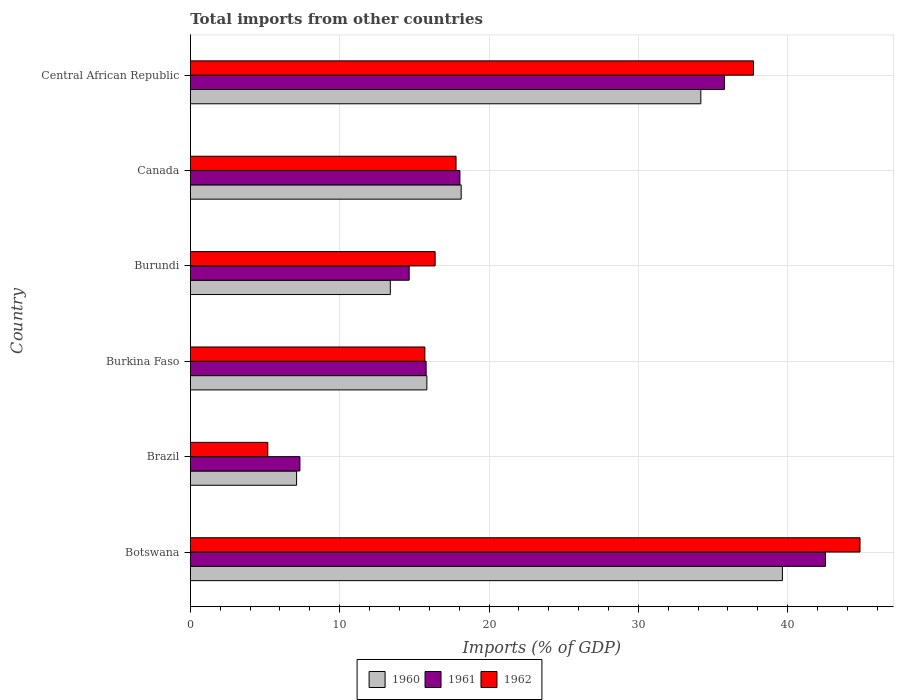How many different coloured bars are there?
Your response must be concise. 3. Are the number of bars per tick equal to the number of legend labels?
Provide a succinct answer. Yes. Are the number of bars on each tick of the Y-axis equal?
Your answer should be compact. Yes. How many bars are there on the 2nd tick from the top?
Your answer should be very brief. 3. How many bars are there on the 6th tick from the bottom?
Provide a succinct answer. 3. What is the label of the 6th group of bars from the top?
Provide a short and direct response. Botswana. In how many cases, is the number of bars for a given country not equal to the number of legend labels?
Ensure brevity in your answer.  0. What is the total imports in 1962 in Burundi?
Ensure brevity in your answer.  16.39. Across all countries, what is the maximum total imports in 1962?
Provide a succinct answer. 44.84. Across all countries, what is the minimum total imports in 1961?
Provide a short and direct response. 7.34. In which country was the total imports in 1960 maximum?
Offer a terse response. Botswana. In which country was the total imports in 1960 minimum?
Offer a very short reply. Brazil. What is the total total imports in 1962 in the graph?
Your response must be concise. 137.63. What is the difference between the total imports in 1962 in Botswana and that in Brazil?
Provide a short and direct response. 39.65. What is the difference between the total imports in 1962 in Central African Republic and the total imports in 1960 in Botswana?
Give a very brief answer. -1.94. What is the average total imports in 1961 per country?
Offer a very short reply. 22.35. What is the difference between the total imports in 1961 and total imports in 1962 in Canada?
Make the answer very short. 0.26. In how many countries, is the total imports in 1960 greater than 8 %?
Make the answer very short. 5. What is the ratio of the total imports in 1962 in Botswana to that in Brazil?
Make the answer very short. 8.64. Is the total imports in 1960 in Botswana less than that in Brazil?
Your answer should be very brief. No. Is the difference between the total imports in 1961 in Brazil and Burkina Faso greater than the difference between the total imports in 1962 in Brazil and Burkina Faso?
Your answer should be compact. Yes. What is the difference between the highest and the second highest total imports in 1961?
Your answer should be compact. 6.76. What is the difference between the highest and the lowest total imports in 1962?
Make the answer very short. 39.65. In how many countries, is the total imports in 1960 greater than the average total imports in 1960 taken over all countries?
Ensure brevity in your answer.  2. What does the 3rd bar from the top in Burkina Faso represents?
Offer a terse response. 1960. What does the 3rd bar from the bottom in Burundi represents?
Offer a very short reply. 1962. Is it the case that in every country, the sum of the total imports in 1962 and total imports in 1961 is greater than the total imports in 1960?
Provide a short and direct response. Yes. Are all the bars in the graph horizontal?
Provide a succinct answer. Yes. How many countries are there in the graph?
Ensure brevity in your answer.  6. Where does the legend appear in the graph?
Ensure brevity in your answer.  Bottom center. What is the title of the graph?
Your response must be concise. Total imports from other countries. Does "1985" appear as one of the legend labels in the graph?
Give a very brief answer. No. What is the label or title of the X-axis?
Make the answer very short. Imports (% of GDP). What is the label or title of the Y-axis?
Keep it short and to the point. Country. What is the Imports (% of GDP) in 1960 in Botswana?
Your answer should be compact. 39.64. What is the Imports (% of GDP) in 1961 in Botswana?
Provide a succinct answer. 42.53. What is the Imports (% of GDP) in 1962 in Botswana?
Offer a very short reply. 44.84. What is the Imports (% of GDP) in 1960 in Brazil?
Offer a terse response. 7.12. What is the Imports (% of GDP) of 1961 in Brazil?
Give a very brief answer. 7.34. What is the Imports (% of GDP) in 1962 in Brazil?
Make the answer very short. 5.19. What is the Imports (% of GDP) of 1960 in Burkina Faso?
Make the answer very short. 15.84. What is the Imports (% of GDP) of 1961 in Burkina Faso?
Give a very brief answer. 15.79. What is the Imports (% of GDP) in 1962 in Burkina Faso?
Offer a terse response. 15.71. What is the Imports (% of GDP) of 1960 in Burundi?
Your answer should be very brief. 13.39. What is the Imports (% of GDP) in 1961 in Burundi?
Provide a short and direct response. 14.66. What is the Imports (% of GDP) in 1962 in Burundi?
Your answer should be compact. 16.39. What is the Imports (% of GDP) of 1960 in Canada?
Ensure brevity in your answer.  18.14. What is the Imports (% of GDP) in 1961 in Canada?
Give a very brief answer. 18.05. What is the Imports (% of GDP) in 1962 in Canada?
Your answer should be very brief. 17.79. What is the Imports (% of GDP) of 1960 in Central African Republic?
Make the answer very short. 34.18. What is the Imports (% of GDP) in 1961 in Central African Republic?
Your answer should be very brief. 35.76. What is the Imports (% of GDP) of 1962 in Central African Republic?
Offer a very short reply. 37.7. Across all countries, what is the maximum Imports (% of GDP) of 1960?
Offer a terse response. 39.64. Across all countries, what is the maximum Imports (% of GDP) of 1961?
Your answer should be very brief. 42.53. Across all countries, what is the maximum Imports (% of GDP) in 1962?
Offer a very short reply. 44.84. Across all countries, what is the minimum Imports (% of GDP) in 1960?
Offer a terse response. 7.12. Across all countries, what is the minimum Imports (% of GDP) of 1961?
Make the answer very short. 7.34. Across all countries, what is the minimum Imports (% of GDP) of 1962?
Make the answer very short. 5.19. What is the total Imports (% of GDP) in 1960 in the graph?
Keep it short and to the point. 128.31. What is the total Imports (% of GDP) of 1961 in the graph?
Your response must be concise. 134.12. What is the total Imports (% of GDP) of 1962 in the graph?
Make the answer very short. 137.63. What is the difference between the Imports (% of GDP) of 1960 in Botswana and that in Brazil?
Your answer should be very brief. 32.53. What is the difference between the Imports (% of GDP) of 1961 in Botswana and that in Brazil?
Provide a succinct answer. 35.19. What is the difference between the Imports (% of GDP) of 1962 in Botswana and that in Brazil?
Offer a terse response. 39.65. What is the difference between the Imports (% of GDP) in 1960 in Botswana and that in Burkina Faso?
Your answer should be compact. 23.8. What is the difference between the Imports (% of GDP) of 1961 in Botswana and that in Burkina Faso?
Make the answer very short. 26.74. What is the difference between the Imports (% of GDP) in 1962 in Botswana and that in Burkina Faso?
Keep it short and to the point. 29.13. What is the difference between the Imports (% of GDP) in 1960 in Botswana and that in Burundi?
Ensure brevity in your answer.  26.25. What is the difference between the Imports (% of GDP) in 1961 in Botswana and that in Burundi?
Ensure brevity in your answer.  27.87. What is the difference between the Imports (% of GDP) of 1962 in Botswana and that in Burundi?
Make the answer very short. 28.45. What is the difference between the Imports (% of GDP) in 1960 in Botswana and that in Canada?
Your answer should be compact. 21.51. What is the difference between the Imports (% of GDP) in 1961 in Botswana and that in Canada?
Your answer should be compact. 24.47. What is the difference between the Imports (% of GDP) of 1962 in Botswana and that in Canada?
Provide a short and direct response. 27.05. What is the difference between the Imports (% of GDP) of 1960 in Botswana and that in Central African Republic?
Offer a terse response. 5.46. What is the difference between the Imports (% of GDP) of 1961 in Botswana and that in Central African Republic?
Offer a very short reply. 6.76. What is the difference between the Imports (% of GDP) in 1962 in Botswana and that in Central African Republic?
Ensure brevity in your answer.  7.13. What is the difference between the Imports (% of GDP) in 1960 in Brazil and that in Burkina Faso?
Your answer should be compact. -8.72. What is the difference between the Imports (% of GDP) of 1961 in Brazil and that in Burkina Faso?
Your answer should be compact. -8.45. What is the difference between the Imports (% of GDP) of 1962 in Brazil and that in Burkina Faso?
Your answer should be compact. -10.52. What is the difference between the Imports (% of GDP) of 1960 in Brazil and that in Burundi?
Keep it short and to the point. -6.28. What is the difference between the Imports (% of GDP) of 1961 in Brazil and that in Burundi?
Offer a terse response. -7.32. What is the difference between the Imports (% of GDP) of 1962 in Brazil and that in Burundi?
Your response must be concise. -11.2. What is the difference between the Imports (% of GDP) of 1960 in Brazil and that in Canada?
Provide a short and direct response. -11.02. What is the difference between the Imports (% of GDP) in 1961 in Brazil and that in Canada?
Give a very brief answer. -10.71. What is the difference between the Imports (% of GDP) in 1962 in Brazil and that in Canada?
Your answer should be very brief. -12.6. What is the difference between the Imports (% of GDP) in 1960 in Brazil and that in Central African Republic?
Ensure brevity in your answer.  -27.06. What is the difference between the Imports (% of GDP) in 1961 in Brazil and that in Central African Republic?
Your response must be concise. -28.42. What is the difference between the Imports (% of GDP) of 1962 in Brazil and that in Central African Republic?
Make the answer very short. -32.52. What is the difference between the Imports (% of GDP) of 1960 in Burkina Faso and that in Burundi?
Provide a succinct answer. 2.45. What is the difference between the Imports (% of GDP) of 1961 in Burkina Faso and that in Burundi?
Provide a short and direct response. 1.13. What is the difference between the Imports (% of GDP) in 1962 in Burkina Faso and that in Burundi?
Keep it short and to the point. -0.69. What is the difference between the Imports (% of GDP) in 1960 in Burkina Faso and that in Canada?
Offer a terse response. -2.3. What is the difference between the Imports (% of GDP) of 1961 in Burkina Faso and that in Canada?
Keep it short and to the point. -2.26. What is the difference between the Imports (% of GDP) of 1962 in Burkina Faso and that in Canada?
Provide a short and direct response. -2.09. What is the difference between the Imports (% of GDP) in 1960 in Burkina Faso and that in Central African Republic?
Ensure brevity in your answer.  -18.34. What is the difference between the Imports (% of GDP) of 1961 in Burkina Faso and that in Central African Republic?
Ensure brevity in your answer.  -19.97. What is the difference between the Imports (% of GDP) in 1962 in Burkina Faso and that in Central African Republic?
Give a very brief answer. -22. What is the difference between the Imports (% of GDP) of 1960 in Burundi and that in Canada?
Keep it short and to the point. -4.74. What is the difference between the Imports (% of GDP) of 1961 in Burundi and that in Canada?
Offer a terse response. -3.4. What is the difference between the Imports (% of GDP) in 1962 in Burundi and that in Canada?
Offer a very short reply. -1.4. What is the difference between the Imports (% of GDP) in 1960 in Burundi and that in Central African Republic?
Offer a terse response. -20.79. What is the difference between the Imports (% of GDP) of 1961 in Burundi and that in Central African Republic?
Keep it short and to the point. -21.11. What is the difference between the Imports (% of GDP) of 1962 in Burundi and that in Central African Republic?
Your answer should be very brief. -21.31. What is the difference between the Imports (% of GDP) in 1960 in Canada and that in Central African Republic?
Offer a terse response. -16.05. What is the difference between the Imports (% of GDP) of 1961 in Canada and that in Central African Republic?
Your response must be concise. -17.71. What is the difference between the Imports (% of GDP) of 1962 in Canada and that in Central African Republic?
Provide a short and direct response. -19.91. What is the difference between the Imports (% of GDP) in 1960 in Botswana and the Imports (% of GDP) in 1961 in Brazil?
Give a very brief answer. 32.3. What is the difference between the Imports (% of GDP) of 1960 in Botswana and the Imports (% of GDP) of 1962 in Brazil?
Give a very brief answer. 34.45. What is the difference between the Imports (% of GDP) in 1961 in Botswana and the Imports (% of GDP) in 1962 in Brazil?
Your answer should be compact. 37.34. What is the difference between the Imports (% of GDP) of 1960 in Botswana and the Imports (% of GDP) of 1961 in Burkina Faso?
Your answer should be very brief. 23.85. What is the difference between the Imports (% of GDP) of 1960 in Botswana and the Imports (% of GDP) of 1962 in Burkina Faso?
Offer a terse response. 23.94. What is the difference between the Imports (% of GDP) in 1961 in Botswana and the Imports (% of GDP) in 1962 in Burkina Faso?
Provide a short and direct response. 26.82. What is the difference between the Imports (% of GDP) in 1960 in Botswana and the Imports (% of GDP) in 1961 in Burundi?
Your answer should be very brief. 24.99. What is the difference between the Imports (% of GDP) of 1960 in Botswana and the Imports (% of GDP) of 1962 in Burundi?
Your response must be concise. 23.25. What is the difference between the Imports (% of GDP) in 1961 in Botswana and the Imports (% of GDP) in 1962 in Burundi?
Offer a very short reply. 26.13. What is the difference between the Imports (% of GDP) of 1960 in Botswana and the Imports (% of GDP) of 1961 in Canada?
Provide a succinct answer. 21.59. What is the difference between the Imports (% of GDP) of 1960 in Botswana and the Imports (% of GDP) of 1962 in Canada?
Ensure brevity in your answer.  21.85. What is the difference between the Imports (% of GDP) of 1961 in Botswana and the Imports (% of GDP) of 1962 in Canada?
Keep it short and to the point. 24.73. What is the difference between the Imports (% of GDP) in 1960 in Botswana and the Imports (% of GDP) in 1961 in Central African Republic?
Keep it short and to the point. 3.88. What is the difference between the Imports (% of GDP) of 1960 in Botswana and the Imports (% of GDP) of 1962 in Central African Republic?
Provide a succinct answer. 1.94. What is the difference between the Imports (% of GDP) of 1961 in Botswana and the Imports (% of GDP) of 1962 in Central African Republic?
Make the answer very short. 4.82. What is the difference between the Imports (% of GDP) of 1960 in Brazil and the Imports (% of GDP) of 1961 in Burkina Faso?
Your answer should be compact. -8.67. What is the difference between the Imports (% of GDP) in 1960 in Brazil and the Imports (% of GDP) in 1962 in Burkina Faso?
Your answer should be compact. -8.59. What is the difference between the Imports (% of GDP) in 1961 in Brazil and the Imports (% of GDP) in 1962 in Burkina Faso?
Ensure brevity in your answer.  -8.37. What is the difference between the Imports (% of GDP) in 1960 in Brazil and the Imports (% of GDP) in 1961 in Burundi?
Your answer should be compact. -7.54. What is the difference between the Imports (% of GDP) of 1960 in Brazil and the Imports (% of GDP) of 1962 in Burundi?
Provide a short and direct response. -9.28. What is the difference between the Imports (% of GDP) of 1961 in Brazil and the Imports (% of GDP) of 1962 in Burundi?
Provide a short and direct response. -9.05. What is the difference between the Imports (% of GDP) in 1960 in Brazil and the Imports (% of GDP) in 1961 in Canada?
Your response must be concise. -10.93. What is the difference between the Imports (% of GDP) in 1960 in Brazil and the Imports (% of GDP) in 1962 in Canada?
Provide a short and direct response. -10.68. What is the difference between the Imports (% of GDP) in 1961 in Brazil and the Imports (% of GDP) in 1962 in Canada?
Provide a succinct answer. -10.45. What is the difference between the Imports (% of GDP) of 1960 in Brazil and the Imports (% of GDP) of 1961 in Central African Republic?
Your answer should be compact. -28.64. What is the difference between the Imports (% of GDP) in 1960 in Brazil and the Imports (% of GDP) in 1962 in Central African Republic?
Provide a short and direct response. -30.59. What is the difference between the Imports (% of GDP) of 1961 in Brazil and the Imports (% of GDP) of 1962 in Central African Republic?
Ensure brevity in your answer.  -30.37. What is the difference between the Imports (% of GDP) in 1960 in Burkina Faso and the Imports (% of GDP) in 1961 in Burundi?
Offer a very short reply. 1.18. What is the difference between the Imports (% of GDP) of 1960 in Burkina Faso and the Imports (% of GDP) of 1962 in Burundi?
Your response must be concise. -0.55. What is the difference between the Imports (% of GDP) of 1961 in Burkina Faso and the Imports (% of GDP) of 1962 in Burundi?
Your answer should be compact. -0.6. What is the difference between the Imports (% of GDP) in 1960 in Burkina Faso and the Imports (% of GDP) in 1961 in Canada?
Your answer should be compact. -2.21. What is the difference between the Imports (% of GDP) in 1960 in Burkina Faso and the Imports (% of GDP) in 1962 in Canada?
Your response must be concise. -1.95. What is the difference between the Imports (% of GDP) of 1961 in Burkina Faso and the Imports (% of GDP) of 1962 in Canada?
Your answer should be very brief. -2. What is the difference between the Imports (% of GDP) in 1960 in Burkina Faso and the Imports (% of GDP) in 1961 in Central African Republic?
Keep it short and to the point. -19.92. What is the difference between the Imports (% of GDP) of 1960 in Burkina Faso and the Imports (% of GDP) of 1962 in Central African Republic?
Provide a succinct answer. -21.87. What is the difference between the Imports (% of GDP) in 1961 in Burkina Faso and the Imports (% of GDP) in 1962 in Central African Republic?
Keep it short and to the point. -21.91. What is the difference between the Imports (% of GDP) in 1960 in Burundi and the Imports (% of GDP) in 1961 in Canada?
Ensure brevity in your answer.  -4.66. What is the difference between the Imports (% of GDP) of 1960 in Burundi and the Imports (% of GDP) of 1962 in Canada?
Give a very brief answer. -4.4. What is the difference between the Imports (% of GDP) of 1961 in Burundi and the Imports (% of GDP) of 1962 in Canada?
Offer a very short reply. -3.14. What is the difference between the Imports (% of GDP) of 1960 in Burundi and the Imports (% of GDP) of 1961 in Central African Republic?
Give a very brief answer. -22.37. What is the difference between the Imports (% of GDP) in 1960 in Burundi and the Imports (% of GDP) in 1962 in Central African Republic?
Provide a short and direct response. -24.31. What is the difference between the Imports (% of GDP) in 1961 in Burundi and the Imports (% of GDP) in 1962 in Central African Republic?
Offer a terse response. -23.05. What is the difference between the Imports (% of GDP) of 1960 in Canada and the Imports (% of GDP) of 1961 in Central African Republic?
Ensure brevity in your answer.  -17.63. What is the difference between the Imports (% of GDP) in 1960 in Canada and the Imports (% of GDP) in 1962 in Central African Republic?
Offer a terse response. -19.57. What is the difference between the Imports (% of GDP) of 1961 in Canada and the Imports (% of GDP) of 1962 in Central African Republic?
Your response must be concise. -19.65. What is the average Imports (% of GDP) in 1960 per country?
Provide a succinct answer. 21.39. What is the average Imports (% of GDP) of 1961 per country?
Keep it short and to the point. 22.35. What is the average Imports (% of GDP) in 1962 per country?
Make the answer very short. 22.94. What is the difference between the Imports (% of GDP) in 1960 and Imports (% of GDP) in 1961 in Botswana?
Give a very brief answer. -2.88. What is the difference between the Imports (% of GDP) in 1960 and Imports (% of GDP) in 1962 in Botswana?
Your response must be concise. -5.2. What is the difference between the Imports (% of GDP) in 1961 and Imports (% of GDP) in 1962 in Botswana?
Your answer should be compact. -2.31. What is the difference between the Imports (% of GDP) of 1960 and Imports (% of GDP) of 1961 in Brazil?
Your answer should be very brief. -0.22. What is the difference between the Imports (% of GDP) in 1960 and Imports (% of GDP) in 1962 in Brazil?
Your answer should be very brief. 1.93. What is the difference between the Imports (% of GDP) in 1961 and Imports (% of GDP) in 1962 in Brazil?
Your answer should be very brief. 2.15. What is the difference between the Imports (% of GDP) in 1960 and Imports (% of GDP) in 1961 in Burkina Faso?
Provide a short and direct response. 0.05. What is the difference between the Imports (% of GDP) of 1960 and Imports (% of GDP) of 1962 in Burkina Faso?
Make the answer very short. 0.13. What is the difference between the Imports (% of GDP) in 1961 and Imports (% of GDP) in 1962 in Burkina Faso?
Provide a short and direct response. 0.08. What is the difference between the Imports (% of GDP) of 1960 and Imports (% of GDP) of 1961 in Burundi?
Provide a succinct answer. -1.26. What is the difference between the Imports (% of GDP) of 1960 and Imports (% of GDP) of 1962 in Burundi?
Provide a succinct answer. -3. What is the difference between the Imports (% of GDP) in 1961 and Imports (% of GDP) in 1962 in Burundi?
Your answer should be very brief. -1.74. What is the difference between the Imports (% of GDP) in 1960 and Imports (% of GDP) in 1961 in Canada?
Ensure brevity in your answer.  0.08. What is the difference between the Imports (% of GDP) of 1960 and Imports (% of GDP) of 1962 in Canada?
Your response must be concise. 0.34. What is the difference between the Imports (% of GDP) in 1961 and Imports (% of GDP) in 1962 in Canada?
Your answer should be compact. 0.26. What is the difference between the Imports (% of GDP) of 1960 and Imports (% of GDP) of 1961 in Central African Republic?
Your response must be concise. -1.58. What is the difference between the Imports (% of GDP) in 1960 and Imports (% of GDP) in 1962 in Central African Republic?
Your answer should be very brief. -3.52. What is the difference between the Imports (% of GDP) in 1961 and Imports (% of GDP) in 1962 in Central African Republic?
Ensure brevity in your answer.  -1.94. What is the ratio of the Imports (% of GDP) of 1960 in Botswana to that in Brazil?
Offer a terse response. 5.57. What is the ratio of the Imports (% of GDP) in 1961 in Botswana to that in Brazil?
Keep it short and to the point. 5.79. What is the ratio of the Imports (% of GDP) of 1962 in Botswana to that in Brazil?
Provide a short and direct response. 8.64. What is the ratio of the Imports (% of GDP) in 1960 in Botswana to that in Burkina Faso?
Provide a succinct answer. 2.5. What is the ratio of the Imports (% of GDP) in 1961 in Botswana to that in Burkina Faso?
Provide a short and direct response. 2.69. What is the ratio of the Imports (% of GDP) of 1962 in Botswana to that in Burkina Faso?
Ensure brevity in your answer.  2.85. What is the ratio of the Imports (% of GDP) of 1960 in Botswana to that in Burundi?
Offer a very short reply. 2.96. What is the ratio of the Imports (% of GDP) in 1961 in Botswana to that in Burundi?
Provide a succinct answer. 2.9. What is the ratio of the Imports (% of GDP) of 1962 in Botswana to that in Burundi?
Keep it short and to the point. 2.74. What is the ratio of the Imports (% of GDP) in 1960 in Botswana to that in Canada?
Offer a terse response. 2.19. What is the ratio of the Imports (% of GDP) of 1961 in Botswana to that in Canada?
Provide a short and direct response. 2.36. What is the ratio of the Imports (% of GDP) of 1962 in Botswana to that in Canada?
Give a very brief answer. 2.52. What is the ratio of the Imports (% of GDP) of 1960 in Botswana to that in Central African Republic?
Provide a succinct answer. 1.16. What is the ratio of the Imports (% of GDP) in 1961 in Botswana to that in Central African Republic?
Your response must be concise. 1.19. What is the ratio of the Imports (% of GDP) of 1962 in Botswana to that in Central African Republic?
Ensure brevity in your answer.  1.19. What is the ratio of the Imports (% of GDP) in 1960 in Brazil to that in Burkina Faso?
Offer a very short reply. 0.45. What is the ratio of the Imports (% of GDP) in 1961 in Brazil to that in Burkina Faso?
Provide a succinct answer. 0.46. What is the ratio of the Imports (% of GDP) in 1962 in Brazil to that in Burkina Faso?
Ensure brevity in your answer.  0.33. What is the ratio of the Imports (% of GDP) of 1960 in Brazil to that in Burundi?
Make the answer very short. 0.53. What is the ratio of the Imports (% of GDP) in 1961 in Brazil to that in Burundi?
Your response must be concise. 0.5. What is the ratio of the Imports (% of GDP) of 1962 in Brazil to that in Burundi?
Provide a short and direct response. 0.32. What is the ratio of the Imports (% of GDP) of 1960 in Brazil to that in Canada?
Make the answer very short. 0.39. What is the ratio of the Imports (% of GDP) of 1961 in Brazil to that in Canada?
Your answer should be compact. 0.41. What is the ratio of the Imports (% of GDP) in 1962 in Brazil to that in Canada?
Your response must be concise. 0.29. What is the ratio of the Imports (% of GDP) in 1960 in Brazil to that in Central African Republic?
Make the answer very short. 0.21. What is the ratio of the Imports (% of GDP) in 1961 in Brazil to that in Central African Republic?
Your answer should be very brief. 0.21. What is the ratio of the Imports (% of GDP) in 1962 in Brazil to that in Central African Republic?
Provide a succinct answer. 0.14. What is the ratio of the Imports (% of GDP) in 1960 in Burkina Faso to that in Burundi?
Keep it short and to the point. 1.18. What is the ratio of the Imports (% of GDP) of 1961 in Burkina Faso to that in Burundi?
Offer a terse response. 1.08. What is the ratio of the Imports (% of GDP) in 1962 in Burkina Faso to that in Burundi?
Offer a very short reply. 0.96. What is the ratio of the Imports (% of GDP) in 1960 in Burkina Faso to that in Canada?
Your response must be concise. 0.87. What is the ratio of the Imports (% of GDP) of 1961 in Burkina Faso to that in Canada?
Keep it short and to the point. 0.87. What is the ratio of the Imports (% of GDP) of 1962 in Burkina Faso to that in Canada?
Give a very brief answer. 0.88. What is the ratio of the Imports (% of GDP) in 1960 in Burkina Faso to that in Central African Republic?
Your answer should be very brief. 0.46. What is the ratio of the Imports (% of GDP) of 1961 in Burkina Faso to that in Central African Republic?
Your answer should be compact. 0.44. What is the ratio of the Imports (% of GDP) in 1962 in Burkina Faso to that in Central African Republic?
Ensure brevity in your answer.  0.42. What is the ratio of the Imports (% of GDP) in 1960 in Burundi to that in Canada?
Ensure brevity in your answer.  0.74. What is the ratio of the Imports (% of GDP) in 1961 in Burundi to that in Canada?
Your response must be concise. 0.81. What is the ratio of the Imports (% of GDP) in 1962 in Burundi to that in Canada?
Offer a terse response. 0.92. What is the ratio of the Imports (% of GDP) in 1960 in Burundi to that in Central African Republic?
Provide a succinct answer. 0.39. What is the ratio of the Imports (% of GDP) of 1961 in Burundi to that in Central African Republic?
Offer a terse response. 0.41. What is the ratio of the Imports (% of GDP) in 1962 in Burundi to that in Central African Republic?
Your answer should be very brief. 0.43. What is the ratio of the Imports (% of GDP) of 1960 in Canada to that in Central African Republic?
Your answer should be very brief. 0.53. What is the ratio of the Imports (% of GDP) of 1961 in Canada to that in Central African Republic?
Provide a short and direct response. 0.5. What is the ratio of the Imports (% of GDP) in 1962 in Canada to that in Central African Republic?
Give a very brief answer. 0.47. What is the difference between the highest and the second highest Imports (% of GDP) in 1960?
Offer a terse response. 5.46. What is the difference between the highest and the second highest Imports (% of GDP) in 1961?
Offer a terse response. 6.76. What is the difference between the highest and the second highest Imports (% of GDP) of 1962?
Provide a succinct answer. 7.13. What is the difference between the highest and the lowest Imports (% of GDP) of 1960?
Give a very brief answer. 32.53. What is the difference between the highest and the lowest Imports (% of GDP) in 1961?
Offer a terse response. 35.19. What is the difference between the highest and the lowest Imports (% of GDP) of 1962?
Your answer should be very brief. 39.65. 